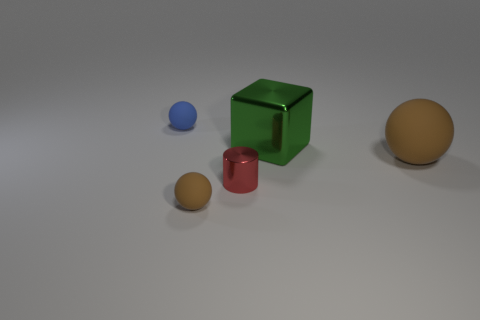Subtract 1 balls. How many balls are left? 2 Add 2 small gray cubes. How many objects exist? 7 Subtract all spheres. How many objects are left? 2 Subtract all small blue balls. Subtract all green shiny cubes. How many objects are left? 3 Add 1 green cubes. How many green cubes are left? 2 Add 5 small rubber balls. How many small rubber balls exist? 7 Subtract 0 green balls. How many objects are left? 5 